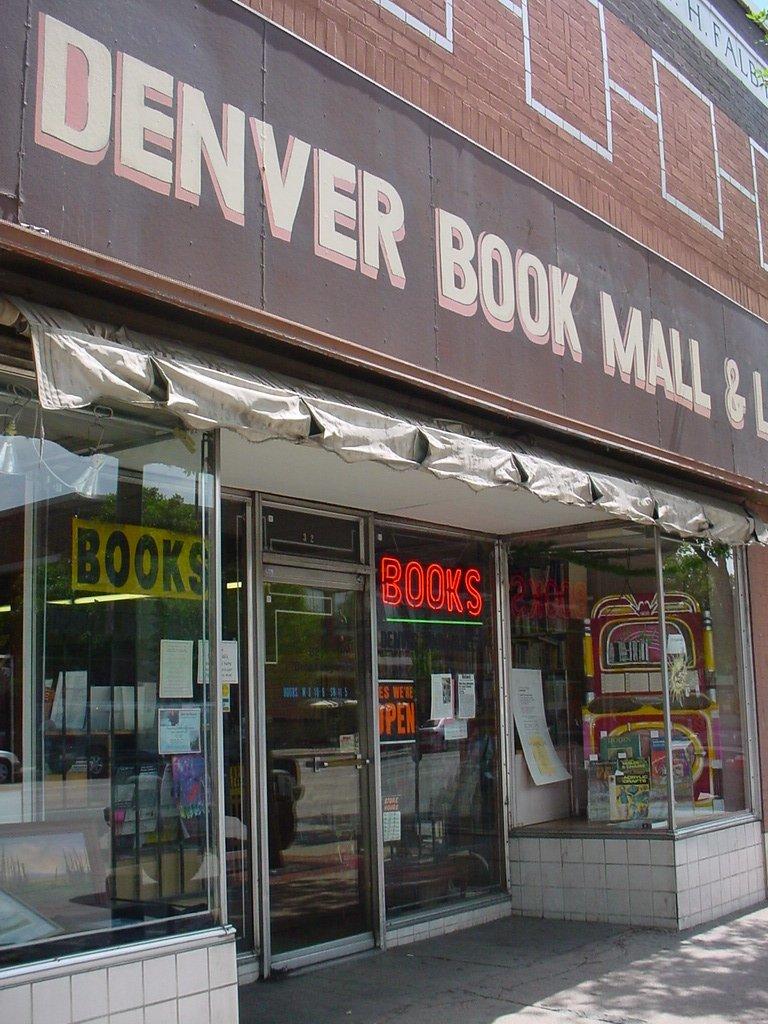Where is the book mall?
Offer a terse response. Denver. What does this store sell?
Offer a very short reply. Books. 